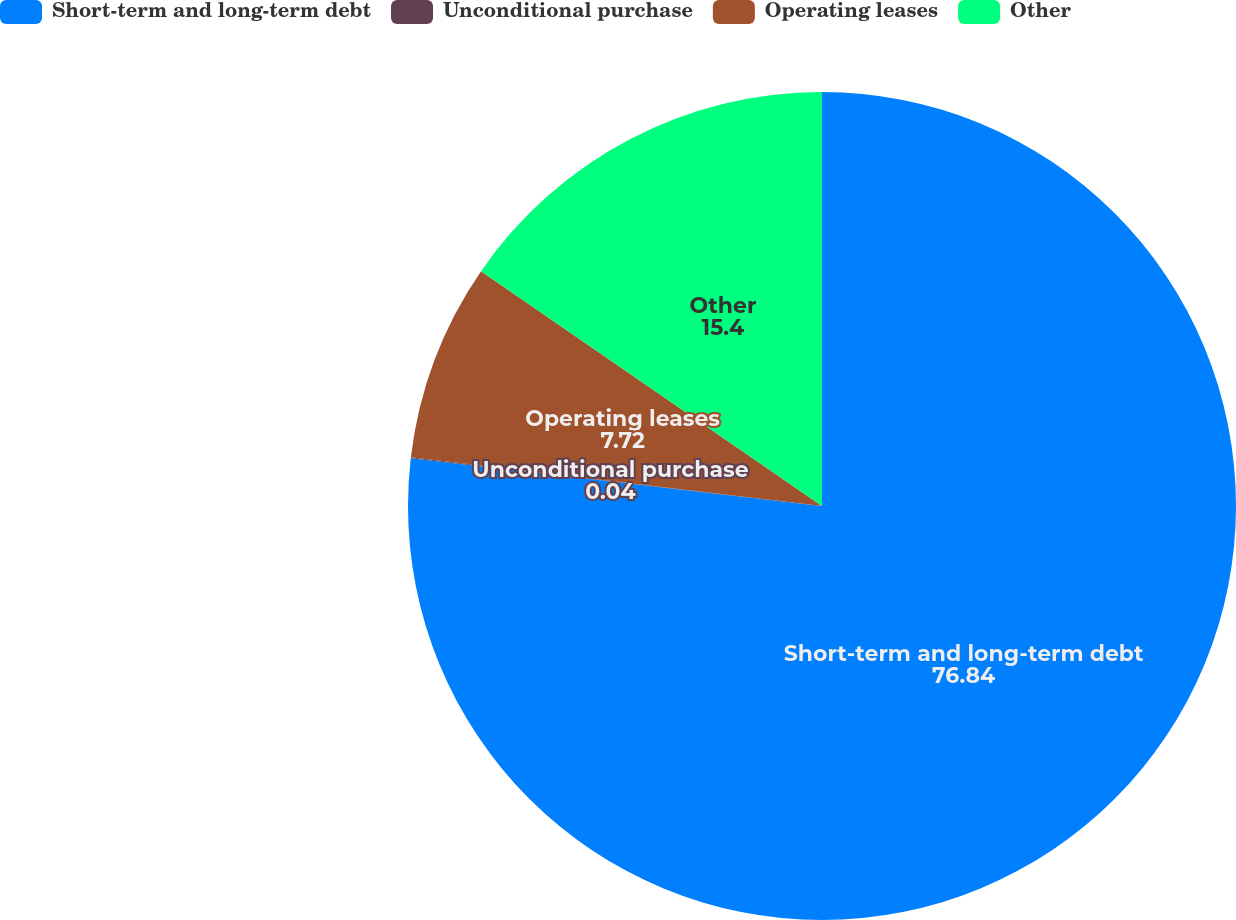<chart> <loc_0><loc_0><loc_500><loc_500><pie_chart><fcel>Short-term and long-term debt<fcel>Unconditional purchase<fcel>Operating leases<fcel>Other<nl><fcel>76.84%<fcel>0.04%<fcel>7.72%<fcel>15.4%<nl></chart> 